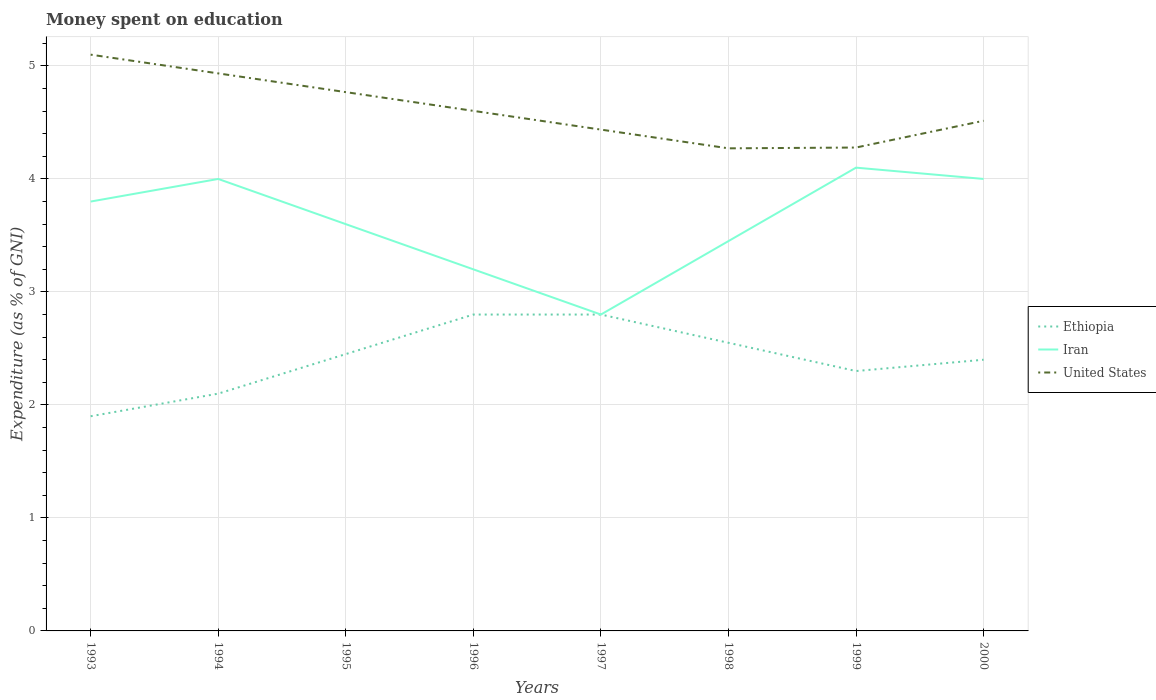How many different coloured lines are there?
Provide a short and direct response. 3. Is the number of lines equal to the number of legend labels?
Your answer should be very brief. Yes. Across all years, what is the maximum amount of money spent on education in Iran?
Give a very brief answer. 2.8. In which year was the amount of money spent on education in United States maximum?
Offer a terse response. 1998. What is the total amount of money spent on education in Iran in the graph?
Offer a terse response. -0.55. What is the difference between the highest and the second highest amount of money spent on education in United States?
Provide a succinct answer. 0.83. What is the difference between the highest and the lowest amount of money spent on education in United States?
Offer a terse response. 3. How many lines are there?
Provide a succinct answer. 3. Where does the legend appear in the graph?
Your answer should be compact. Center right. How many legend labels are there?
Your answer should be very brief. 3. What is the title of the graph?
Offer a very short reply. Money spent on education. What is the label or title of the Y-axis?
Provide a succinct answer. Expenditure (as % of GNI). What is the Expenditure (as % of GNI) in Ethiopia in 1993?
Offer a very short reply. 1.9. What is the Expenditure (as % of GNI) of Iran in 1993?
Provide a succinct answer. 3.8. What is the Expenditure (as % of GNI) of Iran in 1994?
Your answer should be compact. 4. What is the Expenditure (as % of GNI) in United States in 1994?
Your response must be concise. 4.93. What is the Expenditure (as % of GNI) of Ethiopia in 1995?
Ensure brevity in your answer.  2.45. What is the Expenditure (as % of GNI) of Iran in 1995?
Give a very brief answer. 3.6. What is the Expenditure (as % of GNI) of United States in 1995?
Provide a succinct answer. 4.77. What is the Expenditure (as % of GNI) in Ethiopia in 1996?
Ensure brevity in your answer.  2.8. What is the Expenditure (as % of GNI) of United States in 1996?
Provide a succinct answer. 4.6. What is the Expenditure (as % of GNI) of Ethiopia in 1997?
Give a very brief answer. 2.8. What is the Expenditure (as % of GNI) of Iran in 1997?
Give a very brief answer. 2.8. What is the Expenditure (as % of GNI) of United States in 1997?
Give a very brief answer. 4.44. What is the Expenditure (as % of GNI) in Ethiopia in 1998?
Your answer should be compact. 2.55. What is the Expenditure (as % of GNI) of Iran in 1998?
Give a very brief answer. 3.45. What is the Expenditure (as % of GNI) of United States in 1998?
Provide a short and direct response. 4.27. What is the Expenditure (as % of GNI) of Ethiopia in 1999?
Provide a short and direct response. 2.3. What is the Expenditure (as % of GNI) in United States in 1999?
Make the answer very short. 4.28. What is the Expenditure (as % of GNI) in Ethiopia in 2000?
Keep it short and to the point. 2.4. What is the Expenditure (as % of GNI) in Iran in 2000?
Your answer should be compact. 4. What is the Expenditure (as % of GNI) of United States in 2000?
Your answer should be compact. 4.51. Across all years, what is the minimum Expenditure (as % of GNI) of Iran?
Your answer should be very brief. 2.8. Across all years, what is the minimum Expenditure (as % of GNI) in United States?
Provide a short and direct response. 4.27. What is the total Expenditure (as % of GNI) of Ethiopia in the graph?
Offer a very short reply. 19.3. What is the total Expenditure (as % of GNI) in Iran in the graph?
Ensure brevity in your answer.  28.95. What is the total Expenditure (as % of GNI) in United States in the graph?
Provide a succinct answer. 36.91. What is the difference between the Expenditure (as % of GNI) of Ethiopia in 1993 and that in 1994?
Offer a very short reply. -0.2. What is the difference between the Expenditure (as % of GNI) in United States in 1993 and that in 1994?
Ensure brevity in your answer.  0.17. What is the difference between the Expenditure (as % of GNI) of Ethiopia in 1993 and that in 1995?
Provide a short and direct response. -0.55. What is the difference between the Expenditure (as % of GNI) in Iran in 1993 and that in 1995?
Make the answer very short. 0.2. What is the difference between the Expenditure (as % of GNI) of United States in 1993 and that in 1995?
Give a very brief answer. 0.33. What is the difference between the Expenditure (as % of GNI) of United States in 1993 and that in 1996?
Your response must be concise. 0.5. What is the difference between the Expenditure (as % of GNI) of Iran in 1993 and that in 1997?
Make the answer very short. 1. What is the difference between the Expenditure (as % of GNI) in United States in 1993 and that in 1997?
Make the answer very short. 0.66. What is the difference between the Expenditure (as % of GNI) of Ethiopia in 1993 and that in 1998?
Ensure brevity in your answer.  -0.65. What is the difference between the Expenditure (as % of GNI) in United States in 1993 and that in 1998?
Make the answer very short. 0.83. What is the difference between the Expenditure (as % of GNI) in Ethiopia in 1993 and that in 1999?
Keep it short and to the point. -0.4. What is the difference between the Expenditure (as % of GNI) of Iran in 1993 and that in 1999?
Your answer should be compact. -0.3. What is the difference between the Expenditure (as % of GNI) in United States in 1993 and that in 1999?
Give a very brief answer. 0.82. What is the difference between the Expenditure (as % of GNI) of Iran in 1993 and that in 2000?
Provide a succinct answer. -0.2. What is the difference between the Expenditure (as % of GNI) of United States in 1993 and that in 2000?
Provide a short and direct response. 0.59. What is the difference between the Expenditure (as % of GNI) of Ethiopia in 1994 and that in 1995?
Keep it short and to the point. -0.35. What is the difference between the Expenditure (as % of GNI) of Iran in 1994 and that in 1995?
Your answer should be very brief. 0.4. What is the difference between the Expenditure (as % of GNI) of United States in 1994 and that in 1995?
Offer a very short reply. 0.17. What is the difference between the Expenditure (as % of GNI) of Iran in 1994 and that in 1996?
Offer a very short reply. 0.8. What is the difference between the Expenditure (as % of GNI) in United States in 1994 and that in 1996?
Your answer should be compact. 0.33. What is the difference between the Expenditure (as % of GNI) of United States in 1994 and that in 1997?
Give a very brief answer. 0.5. What is the difference between the Expenditure (as % of GNI) of Ethiopia in 1994 and that in 1998?
Your answer should be very brief. -0.45. What is the difference between the Expenditure (as % of GNI) in Iran in 1994 and that in 1998?
Ensure brevity in your answer.  0.55. What is the difference between the Expenditure (as % of GNI) of United States in 1994 and that in 1998?
Your response must be concise. 0.66. What is the difference between the Expenditure (as % of GNI) of Iran in 1994 and that in 1999?
Ensure brevity in your answer.  -0.1. What is the difference between the Expenditure (as % of GNI) in United States in 1994 and that in 1999?
Give a very brief answer. 0.66. What is the difference between the Expenditure (as % of GNI) in Ethiopia in 1994 and that in 2000?
Ensure brevity in your answer.  -0.3. What is the difference between the Expenditure (as % of GNI) of United States in 1994 and that in 2000?
Your answer should be compact. 0.42. What is the difference between the Expenditure (as % of GNI) of Ethiopia in 1995 and that in 1996?
Keep it short and to the point. -0.35. What is the difference between the Expenditure (as % of GNI) of Iran in 1995 and that in 1996?
Make the answer very short. 0.4. What is the difference between the Expenditure (as % of GNI) in United States in 1995 and that in 1996?
Your answer should be compact. 0.17. What is the difference between the Expenditure (as % of GNI) in Ethiopia in 1995 and that in 1997?
Offer a terse response. -0.35. What is the difference between the Expenditure (as % of GNI) of Iran in 1995 and that in 1997?
Provide a short and direct response. 0.8. What is the difference between the Expenditure (as % of GNI) of United States in 1995 and that in 1997?
Ensure brevity in your answer.  0.33. What is the difference between the Expenditure (as % of GNI) in United States in 1995 and that in 1998?
Ensure brevity in your answer.  0.5. What is the difference between the Expenditure (as % of GNI) in United States in 1995 and that in 1999?
Keep it short and to the point. 0.49. What is the difference between the Expenditure (as % of GNI) in Iran in 1995 and that in 2000?
Make the answer very short. -0.4. What is the difference between the Expenditure (as % of GNI) in United States in 1995 and that in 2000?
Make the answer very short. 0.25. What is the difference between the Expenditure (as % of GNI) of Iran in 1996 and that in 1997?
Provide a short and direct response. 0.4. What is the difference between the Expenditure (as % of GNI) of United States in 1996 and that in 1997?
Your response must be concise. 0.17. What is the difference between the Expenditure (as % of GNI) in Ethiopia in 1996 and that in 1998?
Provide a succinct answer. 0.25. What is the difference between the Expenditure (as % of GNI) of Iran in 1996 and that in 1998?
Give a very brief answer. -0.25. What is the difference between the Expenditure (as % of GNI) of United States in 1996 and that in 1998?
Provide a short and direct response. 0.33. What is the difference between the Expenditure (as % of GNI) of United States in 1996 and that in 1999?
Your answer should be compact. 0.32. What is the difference between the Expenditure (as % of GNI) in United States in 1996 and that in 2000?
Your answer should be very brief. 0.09. What is the difference between the Expenditure (as % of GNI) of Iran in 1997 and that in 1998?
Make the answer very short. -0.65. What is the difference between the Expenditure (as % of GNI) in United States in 1997 and that in 1998?
Provide a succinct answer. 0.17. What is the difference between the Expenditure (as % of GNI) in United States in 1997 and that in 1999?
Offer a very short reply. 0.16. What is the difference between the Expenditure (as % of GNI) of Ethiopia in 1997 and that in 2000?
Give a very brief answer. 0.4. What is the difference between the Expenditure (as % of GNI) in United States in 1997 and that in 2000?
Offer a terse response. -0.08. What is the difference between the Expenditure (as % of GNI) of Iran in 1998 and that in 1999?
Give a very brief answer. -0.65. What is the difference between the Expenditure (as % of GNI) in United States in 1998 and that in 1999?
Your answer should be compact. -0.01. What is the difference between the Expenditure (as % of GNI) of Iran in 1998 and that in 2000?
Ensure brevity in your answer.  -0.55. What is the difference between the Expenditure (as % of GNI) in United States in 1998 and that in 2000?
Provide a succinct answer. -0.24. What is the difference between the Expenditure (as % of GNI) in Ethiopia in 1999 and that in 2000?
Make the answer very short. -0.1. What is the difference between the Expenditure (as % of GNI) of United States in 1999 and that in 2000?
Your answer should be very brief. -0.24. What is the difference between the Expenditure (as % of GNI) of Ethiopia in 1993 and the Expenditure (as % of GNI) of Iran in 1994?
Ensure brevity in your answer.  -2.1. What is the difference between the Expenditure (as % of GNI) in Ethiopia in 1993 and the Expenditure (as % of GNI) in United States in 1994?
Your answer should be very brief. -3.03. What is the difference between the Expenditure (as % of GNI) in Iran in 1993 and the Expenditure (as % of GNI) in United States in 1994?
Offer a very short reply. -1.13. What is the difference between the Expenditure (as % of GNI) of Ethiopia in 1993 and the Expenditure (as % of GNI) of Iran in 1995?
Your answer should be compact. -1.7. What is the difference between the Expenditure (as % of GNI) in Ethiopia in 1993 and the Expenditure (as % of GNI) in United States in 1995?
Ensure brevity in your answer.  -2.87. What is the difference between the Expenditure (as % of GNI) of Iran in 1993 and the Expenditure (as % of GNI) of United States in 1995?
Make the answer very short. -0.97. What is the difference between the Expenditure (as % of GNI) of Ethiopia in 1993 and the Expenditure (as % of GNI) of United States in 1996?
Your response must be concise. -2.7. What is the difference between the Expenditure (as % of GNI) of Iran in 1993 and the Expenditure (as % of GNI) of United States in 1996?
Offer a terse response. -0.8. What is the difference between the Expenditure (as % of GNI) of Ethiopia in 1993 and the Expenditure (as % of GNI) of United States in 1997?
Provide a succinct answer. -2.54. What is the difference between the Expenditure (as % of GNI) of Iran in 1993 and the Expenditure (as % of GNI) of United States in 1997?
Provide a succinct answer. -0.64. What is the difference between the Expenditure (as % of GNI) in Ethiopia in 1993 and the Expenditure (as % of GNI) in Iran in 1998?
Keep it short and to the point. -1.55. What is the difference between the Expenditure (as % of GNI) in Ethiopia in 1993 and the Expenditure (as % of GNI) in United States in 1998?
Keep it short and to the point. -2.37. What is the difference between the Expenditure (as % of GNI) in Iran in 1993 and the Expenditure (as % of GNI) in United States in 1998?
Your answer should be very brief. -0.47. What is the difference between the Expenditure (as % of GNI) in Ethiopia in 1993 and the Expenditure (as % of GNI) in United States in 1999?
Your answer should be compact. -2.38. What is the difference between the Expenditure (as % of GNI) of Iran in 1993 and the Expenditure (as % of GNI) of United States in 1999?
Offer a very short reply. -0.48. What is the difference between the Expenditure (as % of GNI) of Ethiopia in 1993 and the Expenditure (as % of GNI) of United States in 2000?
Your answer should be compact. -2.61. What is the difference between the Expenditure (as % of GNI) of Iran in 1993 and the Expenditure (as % of GNI) of United States in 2000?
Your answer should be compact. -0.71. What is the difference between the Expenditure (as % of GNI) in Ethiopia in 1994 and the Expenditure (as % of GNI) in Iran in 1995?
Make the answer very short. -1.5. What is the difference between the Expenditure (as % of GNI) in Ethiopia in 1994 and the Expenditure (as % of GNI) in United States in 1995?
Offer a terse response. -2.67. What is the difference between the Expenditure (as % of GNI) in Iran in 1994 and the Expenditure (as % of GNI) in United States in 1995?
Your answer should be very brief. -0.77. What is the difference between the Expenditure (as % of GNI) of Ethiopia in 1994 and the Expenditure (as % of GNI) of Iran in 1996?
Offer a very short reply. -1.1. What is the difference between the Expenditure (as % of GNI) in Ethiopia in 1994 and the Expenditure (as % of GNI) in United States in 1996?
Give a very brief answer. -2.5. What is the difference between the Expenditure (as % of GNI) in Iran in 1994 and the Expenditure (as % of GNI) in United States in 1996?
Make the answer very short. -0.6. What is the difference between the Expenditure (as % of GNI) in Ethiopia in 1994 and the Expenditure (as % of GNI) in Iran in 1997?
Keep it short and to the point. -0.7. What is the difference between the Expenditure (as % of GNI) of Ethiopia in 1994 and the Expenditure (as % of GNI) of United States in 1997?
Ensure brevity in your answer.  -2.34. What is the difference between the Expenditure (as % of GNI) of Iran in 1994 and the Expenditure (as % of GNI) of United States in 1997?
Provide a short and direct response. -0.44. What is the difference between the Expenditure (as % of GNI) of Ethiopia in 1994 and the Expenditure (as % of GNI) of Iran in 1998?
Make the answer very short. -1.35. What is the difference between the Expenditure (as % of GNI) in Ethiopia in 1994 and the Expenditure (as % of GNI) in United States in 1998?
Offer a terse response. -2.17. What is the difference between the Expenditure (as % of GNI) in Iran in 1994 and the Expenditure (as % of GNI) in United States in 1998?
Your response must be concise. -0.27. What is the difference between the Expenditure (as % of GNI) in Ethiopia in 1994 and the Expenditure (as % of GNI) in Iran in 1999?
Ensure brevity in your answer.  -2. What is the difference between the Expenditure (as % of GNI) of Ethiopia in 1994 and the Expenditure (as % of GNI) of United States in 1999?
Your answer should be compact. -2.18. What is the difference between the Expenditure (as % of GNI) in Iran in 1994 and the Expenditure (as % of GNI) in United States in 1999?
Make the answer very short. -0.28. What is the difference between the Expenditure (as % of GNI) in Ethiopia in 1994 and the Expenditure (as % of GNI) in United States in 2000?
Make the answer very short. -2.41. What is the difference between the Expenditure (as % of GNI) in Iran in 1994 and the Expenditure (as % of GNI) in United States in 2000?
Offer a very short reply. -0.51. What is the difference between the Expenditure (as % of GNI) of Ethiopia in 1995 and the Expenditure (as % of GNI) of Iran in 1996?
Your answer should be compact. -0.75. What is the difference between the Expenditure (as % of GNI) in Ethiopia in 1995 and the Expenditure (as % of GNI) in United States in 1996?
Provide a succinct answer. -2.15. What is the difference between the Expenditure (as % of GNI) of Iran in 1995 and the Expenditure (as % of GNI) of United States in 1996?
Give a very brief answer. -1. What is the difference between the Expenditure (as % of GNI) in Ethiopia in 1995 and the Expenditure (as % of GNI) in Iran in 1997?
Provide a short and direct response. -0.35. What is the difference between the Expenditure (as % of GNI) in Ethiopia in 1995 and the Expenditure (as % of GNI) in United States in 1997?
Keep it short and to the point. -1.99. What is the difference between the Expenditure (as % of GNI) in Iran in 1995 and the Expenditure (as % of GNI) in United States in 1997?
Make the answer very short. -0.84. What is the difference between the Expenditure (as % of GNI) in Ethiopia in 1995 and the Expenditure (as % of GNI) in United States in 1998?
Your response must be concise. -1.82. What is the difference between the Expenditure (as % of GNI) in Iran in 1995 and the Expenditure (as % of GNI) in United States in 1998?
Give a very brief answer. -0.67. What is the difference between the Expenditure (as % of GNI) of Ethiopia in 1995 and the Expenditure (as % of GNI) of Iran in 1999?
Keep it short and to the point. -1.65. What is the difference between the Expenditure (as % of GNI) of Ethiopia in 1995 and the Expenditure (as % of GNI) of United States in 1999?
Provide a succinct answer. -1.83. What is the difference between the Expenditure (as % of GNI) in Iran in 1995 and the Expenditure (as % of GNI) in United States in 1999?
Offer a very short reply. -0.68. What is the difference between the Expenditure (as % of GNI) in Ethiopia in 1995 and the Expenditure (as % of GNI) in Iran in 2000?
Make the answer very short. -1.55. What is the difference between the Expenditure (as % of GNI) of Ethiopia in 1995 and the Expenditure (as % of GNI) of United States in 2000?
Provide a short and direct response. -2.06. What is the difference between the Expenditure (as % of GNI) of Iran in 1995 and the Expenditure (as % of GNI) of United States in 2000?
Your answer should be compact. -0.91. What is the difference between the Expenditure (as % of GNI) of Ethiopia in 1996 and the Expenditure (as % of GNI) of Iran in 1997?
Offer a terse response. 0. What is the difference between the Expenditure (as % of GNI) of Ethiopia in 1996 and the Expenditure (as % of GNI) of United States in 1997?
Your response must be concise. -1.64. What is the difference between the Expenditure (as % of GNI) of Iran in 1996 and the Expenditure (as % of GNI) of United States in 1997?
Ensure brevity in your answer.  -1.24. What is the difference between the Expenditure (as % of GNI) in Ethiopia in 1996 and the Expenditure (as % of GNI) in Iran in 1998?
Make the answer very short. -0.65. What is the difference between the Expenditure (as % of GNI) of Ethiopia in 1996 and the Expenditure (as % of GNI) of United States in 1998?
Provide a succinct answer. -1.47. What is the difference between the Expenditure (as % of GNI) in Iran in 1996 and the Expenditure (as % of GNI) in United States in 1998?
Make the answer very short. -1.07. What is the difference between the Expenditure (as % of GNI) in Ethiopia in 1996 and the Expenditure (as % of GNI) in United States in 1999?
Your response must be concise. -1.48. What is the difference between the Expenditure (as % of GNI) in Iran in 1996 and the Expenditure (as % of GNI) in United States in 1999?
Give a very brief answer. -1.08. What is the difference between the Expenditure (as % of GNI) of Ethiopia in 1996 and the Expenditure (as % of GNI) of United States in 2000?
Make the answer very short. -1.71. What is the difference between the Expenditure (as % of GNI) in Iran in 1996 and the Expenditure (as % of GNI) in United States in 2000?
Your answer should be very brief. -1.31. What is the difference between the Expenditure (as % of GNI) of Ethiopia in 1997 and the Expenditure (as % of GNI) of Iran in 1998?
Provide a succinct answer. -0.65. What is the difference between the Expenditure (as % of GNI) in Ethiopia in 1997 and the Expenditure (as % of GNI) in United States in 1998?
Offer a very short reply. -1.47. What is the difference between the Expenditure (as % of GNI) in Iran in 1997 and the Expenditure (as % of GNI) in United States in 1998?
Provide a succinct answer. -1.47. What is the difference between the Expenditure (as % of GNI) of Ethiopia in 1997 and the Expenditure (as % of GNI) of Iran in 1999?
Offer a terse response. -1.3. What is the difference between the Expenditure (as % of GNI) of Ethiopia in 1997 and the Expenditure (as % of GNI) of United States in 1999?
Provide a succinct answer. -1.48. What is the difference between the Expenditure (as % of GNI) in Iran in 1997 and the Expenditure (as % of GNI) in United States in 1999?
Your answer should be compact. -1.48. What is the difference between the Expenditure (as % of GNI) in Ethiopia in 1997 and the Expenditure (as % of GNI) in United States in 2000?
Give a very brief answer. -1.71. What is the difference between the Expenditure (as % of GNI) in Iran in 1997 and the Expenditure (as % of GNI) in United States in 2000?
Keep it short and to the point. -1.71. What is the difference between the Expenditure (as % of GNI) of Ethiopia in 1998 and the Expenditure (as % of GNI) of Iran in 1999?
Ensure brevity in your answer.  -1.55. What is the difference between the Expenditure (as % of GNI) of Ethiopia in 1998 and the Expenditure (as % of GNI) of United States in 1999?
Give a very brief answer. -1.73. What is the difference between the Expenditure (as % of GNI) of Iran in 1998 and the Expenditure (as % of GNI) of United States in 1999?
Your answer should be very brief. -0.83. What is the difference between the Expenditure (as % of GNI) in Ethiopia in 1998 and the Expenditure (as % of GNI) in Iran in 2000?
Offer a terse response. -1.45. What is the difference between the Expenditure (as % of GNI) of Ethiopia in 1998 and the Expenditure (as % of GNI) of United States in 2000?
Provide a succinct answer. -1.96. What is the difference between the Expenditure (as % of GNI) of Iran in 1998 and the Expenditure (as % of GNI) of United States in 2000?
Give a very brief answer. -1.06. What is the difference between the Expenditure (as % of GNI) in Ethiopia in 1999 and the Expenditure (as % of GNI) in Iran in 2000?
Offer a terse response. -1.7. What is the difference between the Expenditure (as % of GNI) in Ethiopia in 1999 and the Expenditure (as % of GNI) in United States in 2000?
Provide a succinct answer. -2.21. What is the difference between the Expenditure (as % of GNI) of Iran in 1999 and the Expenditure (as % of GNI) of United States in 2000?
Provide a short and direct response. -0.41. What is the average Expenditure (as % of GNI) in Ethiopia per year?
Offer a very short reply. 2.41. What is the average Expenditure (as % of GNI) of Iran per year?
Your answer should be compact. 3.62. What is the average Expenditure (as % of GNI) of United States per year?
Your answer should be very brief. 4.61. In the year 1993, what is the difference between the Expenditure (as % of GNI) in Ethiopia and Expenditure (as % of GNI) in United States?
Offer a very short reply. -3.2. In the year 1994, what is the difference between the Expenditure (as % of GNI) of Ethiopia and Expenditure (as % of GNI) of United States?
Offer a very short reply. -2.83. In the year 1994, what is the difference between the Expenditure (as % of GNI) in Iran and Expenditure (as % of GNI) in United States?
Provide a short and direct response. -0.93. In the year 1995, what is the difference between the Expenditure (as % of GNI) of Ethiopia and Expenditure (as % of GNI) of Iran?
Provide a short and direct response. -1.15. In the year 1995, what is the difference between the Expenditure (as % of GNI) in Ethiopia and Expenditure (as % of GNI) in United States?
Offer a terse response. -2.32. In the year 1995, what is the difference between the Expenditure (as % of GNI) in Iran and Expenditure (as % of GNI) in United States?
Offer a very short reply. -1.17. In the year 1996, what is the difference between the Expenditure (as % of GNI) of Ethiopia and Expenditure (as % of GNI) of Iran?
Keep it short and to the point. -0.4. In the year 1996, what is the difference between the Expenditure (as % of GNI) of Ethiopia and Expenditure (as % of GNI) of United States?
Give a very brief answer. -1.8. In the year 1996, what is the difference between the Expenditure (as % of GNI) of Iran and Expenditure (as % of GNI) of United States?
Provide a short and direct response. -1.4. In the year 1997, what is the difference between the Expenditure (as % of GNI) in Ethiopia and Expenditure (as % of GNI) in United States?
Offer a very short reply. -1.64. In the year 1997, what is the difference between the Expenditure (as % of GNI) of Iran and Expenditure (as % of GNI) of United States?
Provide a short and direct response. -1.64. In the year 1998, what is the difference between the Expenditure (as % of GNI) of Ethiopia and Expenditure (as % of GNI) of United States?
Offer a terse response. -1.72. In the year 1998, what is the difference between the Expenditure (as % of GNI) in Iran and Expenditure (as % of GNI) in United States?
Keep it short and to the point. -0.82. In the year 1999, what is the difference between the Expenditure (as % of GNI) of Ethiopia and Expenditure (as % of GNI) of United States?
Make the answer very short. -1.98. In the year 1999, what is the difference between the Expenditure (as % of GNI) of Iran and Expenditure (as % of GNI) of United States?
Keep it short and to the point. -0.18. In the year 2000, what is the difference between the Expenditure (as % of GNI) of Ethiopia and Expenditure (as % of GNI) of United States?
Make the answer very short. -2.11. In the year 2000, what is the difference between the Expenditure (as % of GNI) in Iran and Expenditure (as % of GNI) in United States?
Ensure brevity in your answer.  -0.51. What is the ratio of the Expenditure (as % of GNI) of Ethiopia in 1993 to that in 1994?
Provide a succinct answer. 0.9. What is the ratio of the Expenditure (as % of GNI) in United States in 1993 to that in 1994?
Offer a terse response. 1.03. What is the ratio of the Expenditure (as % of GNI) in Ethiopia in 1993 to that in 1995?
Provide a short and direct response. 0.78. What is the ratio of the Expenditure (as % of GNI) in Iran in 1993 to that in 1995?
Offer a terse response. 1.06. What is the ratio of the Expenditure (as % of GNI) of United States in 1993 to that in 1995?
Offer a very short reply. 1.07. What is the ratio of the Expenditure (as % of GNI) of Ethiopia in 1993 to that in 1996?
Provide a succinct answer. 0.68. What is the ratio of the Expenditure (as % of GNI) in Iran in 1993 to that in 1996?
Your answer should be very brief. 1.19. What is the ratio of the Expenditure (as % of GNI) in United States in 1993 to that in 1996?
Your response must be concise. 1.11. What is the ratio of the Expenditure (as % of GNI) of Ethiopia in 1993 to that in 1997?
Give a very brief answer. 0.68. What is the ratio of the Expenditure (as % of GNI) of Iran in 1993 to that in 1997?
Your answer should be very brief. 1.36. What is the ratio of the Expenditure (as % of GNI) in United States in 1993 to that in 1997?
Your response must be concise. 1.15. What is the ratio of the Expenditure (as % of GNI) in Ethiopia in 1993 to that in 1998?
Make the answer very short. 0.75. What is the ratio of the Expenditure (as % of GNI) of Iran in 1993 to that in 1998?
Give a very brief answer. 1.1. What is the ratio of the Expenditure (as % of GNI) in United States in 1993 to that in 1998?
Provide a short and direct response. 1.19. What is the ratio of the Expenditure (as % of GNI) in Ethiopia in 1993 to that in 1999?
Make the answer very short. 0.83. What is the ratio of the Expenditure (as % of GNI) of Iran in 1993 to that in 1999?
Offer a very short reply. 0.93. What is the ratio of the Expenditure (as % of GNI) in United States in 1993 to that in 1999?
Ensure brevity in your answer.  1.19. What is the ratio of the Expenditure (as % of GNI) of Ethiopia in 1993 to that in 2000?
Give a very brief answer. 0.79. What is the ratio of the Expenditure (as % of GNI) in Iran in 1993 to that in 2000?
Provide a short and direct response. 0.95. What is the ratio of the Expenditure (as % of GNI) in United States in 1993 to that in 2000?
Provide a short and direct response. 1.13. What is the ratio of the Expenditure (as % of GNI) in Iran in 1994 to that in 1995?
Provide a succinct answer. 1.11. What is the ratio of the Expenditure (as % of GNI) of United States in 1994 to that in 1995?
Ensure brevity in your answer.  1.03. What is the ratio of the Expenditure (as % of GNI) of Ethiopia in 1994 to that in 1996?
Your answer should be compact. 0.75. What is the ratio of the Expenditure (as % of GNI) of United States in 1994 to that in 1996?
Give a very brief answer. 1.07. What is the ratio of the Expenditure (as % of GNI) of Ethiopia in 1994 to that in 1997?
Provide a short and direct response. 0.75. What is the ratio of the Expenditure (as % of GNI) of Iran in 1994 to that in 1997?
Your answer should be very brief. 1.43. What is the ratio of the Expenditure (as % of GNI) of United States in 1994 to that in 1997?
Offer a terse response. 1.11. What is the ratio of the Expenditure (as % of GNI) of Ethiopia in 1994 to that in 1998?
Offer a terse response. 0.82. What is the ratio of the Expenditure (as % of GNI) of Iran in 1994 to that in 1998?
Offer a very short reply. 1.16. What is the ratio of the Expenditure (as % of GNI) in United States in 1994 to that in 1998?
Give a very brief answer. 1.16. What is the ratio of the Expenditure (as % of GNI) in Ethiopia in 1994 to that in 1999?
Provide a succinct answer. 0.91. What is the ratio of the Expenditure (as % of GNI) in Iran in 1994 to that in 1999?
Provide a short and direct response. 0.98. What is the ratio of the Expenditure (as % of GNI) in United States in 1994 to that in 1999?
Keep it short and to the point. 1.15. What is the ratio of the Expenditure (as % of GNI) of Ethiopia in 1994 to that in 2000?
Your response must be concise. 0.88. What is the ratio of the Expenditure (as % of GNI) of United States in 1994 to that in 2000?
Offer a very short reply. 1.09. What is the ratio of the Expenditure (as % of GNI) of Ethiopia in 1995 to that in 1996?
Make the answer very short. 0.88. What is the ratio of the Expenditure (as % of GNI) in United States in 1995 to that in 1996?
Your response must be concise. 1.04. What is the ratio of the Expenditure (as % of GNI) in Ethiopia in 1995 to that in 1997?
Provide a succinct answer. 0.88. What is the ratio of the Expenditure (as % of GNI) in United States in 1995 to that in 1997?
Offer a terse response. 1.07. What is the ratio of the Expenditure (as % of GNI) of Ethiopia in 1995 to that in 1998?
Make the answer very short. 0.96. What is the ratio of the Expenditure (as % of GNI) of Iran in 1995 to that in 1998?
Your answer should be very brief. 1.04. What is the ratio of the Expenditure (as % of GNI) of United States in 1995 to that in 1998?
Make the answer very short. 1.12. What is the ratio of the Expenditure (as % of GNI) of Ethiopia in 1995 to that in 1999?
Give a very brief answer. 1.07. What is the ratio of the Expenditure (as % of GNI) of Iran in 1995 to that in 1999?
Offer a terse response. 0.88. What is the ratio of the Expenditure (as % of GNI) of United States in 1995 to that in 1999?
Keep it short and to the point. 1.11. What is the ratio of the Expenditure (as % of GNI) of Ethiopia in 1995 to that in 2000?
Offer a terse response. 1.02. What is the ratio of the Expenditure (as % of GNI) in United States in 1995 to that in 2000?
Provide a short and direct response. 1.06. What is the ratio of the Expenditure (as % of GNI) of Ethiopia in 1996 to that in 1997?
Keep it short and to the point. 1. What is the ratio of the Expenditure (as % of GNI) in Iran in 1996 to that in 1997?
Your answer should be very brief. 1.14. What is the ratio of the Expenditure (as % of GNI) in United States in 1996 to that in 1997?
Your answer should be compact. 1.04. What is the ratio of the Expenditure (as % of GNI) in Ethiopia in 1996 to that in 1998?
Your response must be concise. 1.1. What is the ratio of the Expenditure (as % of GNI) in Iran in 1996 to that in 1998?
Ensure brevity in your answer.  0.93. What is the ratio of the Expenditure (as % of GNI) of United States in 1996 to that in 1998?
Make the answer very short. 1.08. What is the ratio of the Expenditure (as % of GNI) in Ethiopia in 1996 to that in 1999?
Offer a terse response. 1.22. What is the ratio of the Expenditure (as % of GNI) of Iran in 1996 to that in 1999?
Provide a short and direct response. 0.78. What is the ratio of the Expenditure (as % of GNI) of United States in 1996 to that in 1999?
Provide a short and direct response. 1.08. What is the ratio of the Expenditure (as % of GNI) in Ethiopia in 1996 to that in 2000?
Make the answer very short. 1.17. What is the ratio of the Expenditure (as % of GNI) of United States in 1996 to that in 2000?
Your answer should be very brief. 1.02. What is the ratio of the Expenditure (as % of GNI) in Ethiopia in 1997 to that in 1998?
Make the answer very short. 1.1. What is the ratio of the Expenditure (as % of GNI) of Iran in 1997 to that in 1998?
Keep it short and to the point. 0.81. What is the ratio of the Expenditure (as % of GNI) of United States in 1997 to that in 1998?
Make the answer very short. 1.04. What is the ratio of the Expenditure (as % of GNI) in Ethiopia in 1997 to that in 1999?
Provide a succinct answer. 1.22. What is the ratio of the Expenditure (as % of GNI) of Iran in 1997 to that in 1999?
Provide a succinct answer. 0.68. What is the ratio of the Expenditure (as % of GNI) in United States in 1997 to that in 1999?
Keep it short and to the point. 1.04. What is the ratio of the Expenditure (as % of GNI) in Iran in 1997 to that in 2000?
Give a very brief answer. 0.7. What is the ratio of the Expenditure (as % of GNI) of United States in 1997 to that in 2000?
Offer a very short reply. 0.98. What is the ratio of the Expenditure (as % of GNI) in Ethiopia in 1998 to that in 1999?
Keep it short and to the point. 1.11. What is the ratio of the Expenditure (as % of GNI) in Iran in 1998 to that in 1999?
Offer a very short reply. 0.84. What is the ratio of the Expenditure (as % of GNI) of United States in 1998 to that in 1999?
Ensure brevity in your answer.  1. What is the ratio of the Expenditure (as % of GNI) of Ethiopia in 1998 to that in 2000?
Your response must be concise. 1.06. What is the ratio of the Expenditure (as % of GNI) in Iran in 1998 to that in 2000?
Make the answer very short. 0.86. What is the ratio of the Expenditure (as % of GNI) of United States in 1998 to that in 2000?
Give a very brief answer. 0.95. What is the ratio of the Expenditure (as % of GNI) of Iran in 1999 to that in 2000?
Your response must be concise. 1.02. What is the ratio of the Expenditure (as % of GNI) in United States in 1999 to that in 2000?
Provide a succinct answer. 0.95. What is the difference between the highest and the second highest Expenditure (as % of GNI) in Ethiopia?
Give a very brief answer. 0. What is the difference between the highest and the second highest Expenditure (as % of GNI) of Iran?
Your response must be concise. 0.1. What is the difference between the highest and the second highest Expenditure (as % of GNI) of United States?
Your response must be concise. 0.17. What is the difference between the highest and the lowest Expenditure (as % of GNI) of Ethiopia?
Your answer should be very brief. 0.9. What is the difference between the highest and the lowest Expenditure (as % of GNI) of Iran?
Make the answer very short. 1.3. What is the difference between the highest and the lowest Expenditure (as % of GNI) in United States?
Keep it short and to the point. 0.83. 